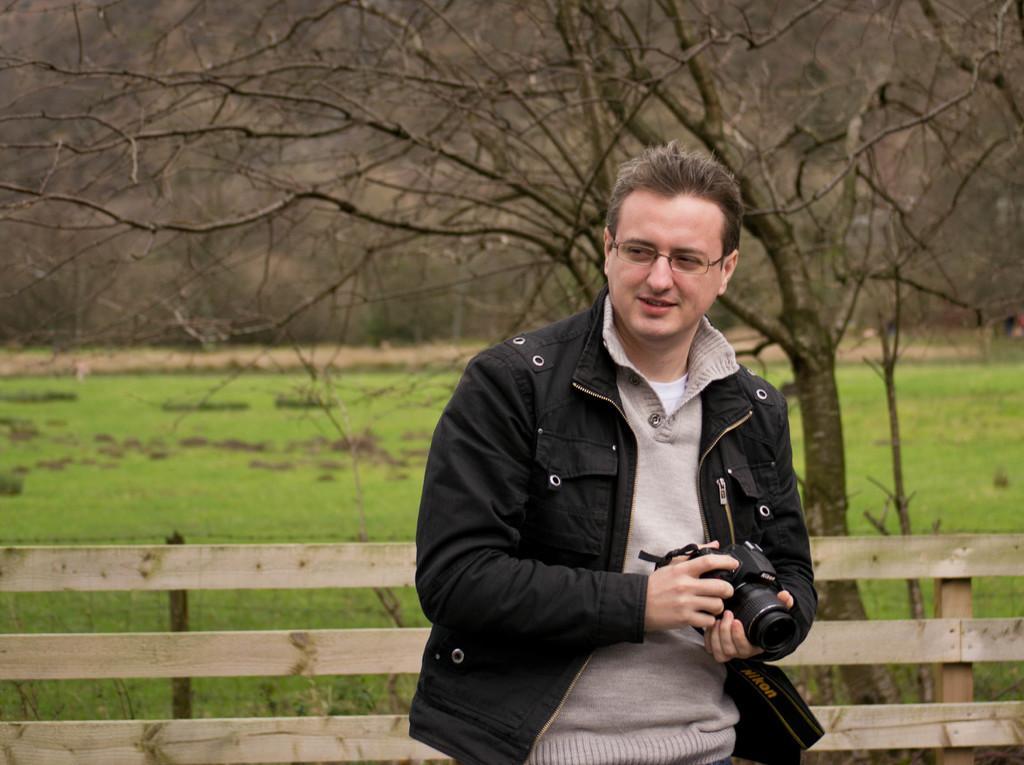Could you give a brief overview of what you see in this image? This is the man standing and smiling. He is holding a camera in his hand. This looks like a wooden fence. In the background, I can see a tree with the branches. This is the grass, which is green in color. 